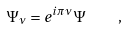Convert formula to latex. <formula><loc_0><loc_0><loc_500><loc_500>\Psi _ { \nu } = e ^ { i \pi \nu } \Psi \quad ,</formula> 